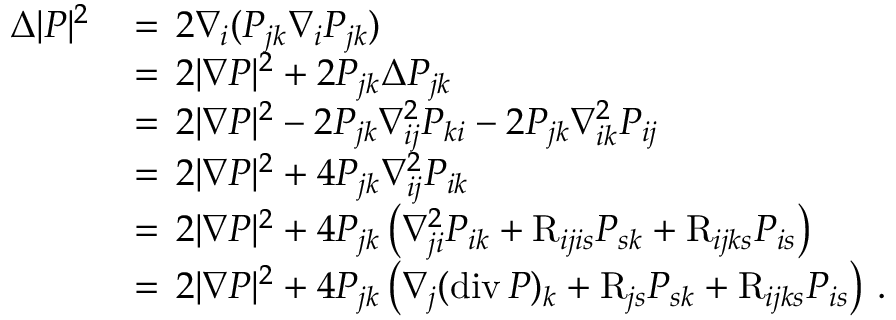Convert formula to latex. <formula><loc_0><loc_0><loc_500><loc_500>\begin{array} { r l } { \Delta | P | ^ { 2 } \, } & { = \, 2 \nabla _ { i } ( P _ { j k } \nabla _ { i } P _ { j k } ) } \\ & { = \, 2 | \nabla P | ^ { 2 } + 2 P _ { j k } \Delta P _ { j k } } \\ & { = \, 2 | \nabla P | ^ { 2 } - 2 P _ { j k } \nabla _ { i j } ^ { 2 } P _ { k i } - 2 P _ { j k } \nabla _ { i k } ^ { 2 } P _ { i j } } \\ & { = \, 2 | \nabla P | ^ { 2 } + 4 P _ { j k } \nabla _ { i j } ^ { 2 } P _ { i k } } \\ & { = \, 2 | \nabla P | ^ { 2 } + 4 P _ { j k } \left ( \nabla _ { j i } ^ { 2 } P _ { i k } + { \mathrm R } _ { i j i s } P _ { s k } + { \mathrm R } _ { i j k s } P _ { i s } \right ) } \\ & { = \, 2 | \nabla P | ^ { 2 } + 4 P _ { j k } \left ( \nabla _ { j } ( d i v \, P ) _ { k } + { \mathrm R } _ { j s } P _ { s k } + { \mathrm R } _ { i j k s } P _ { i s } \right ) \, . } \end{array}</formula> 